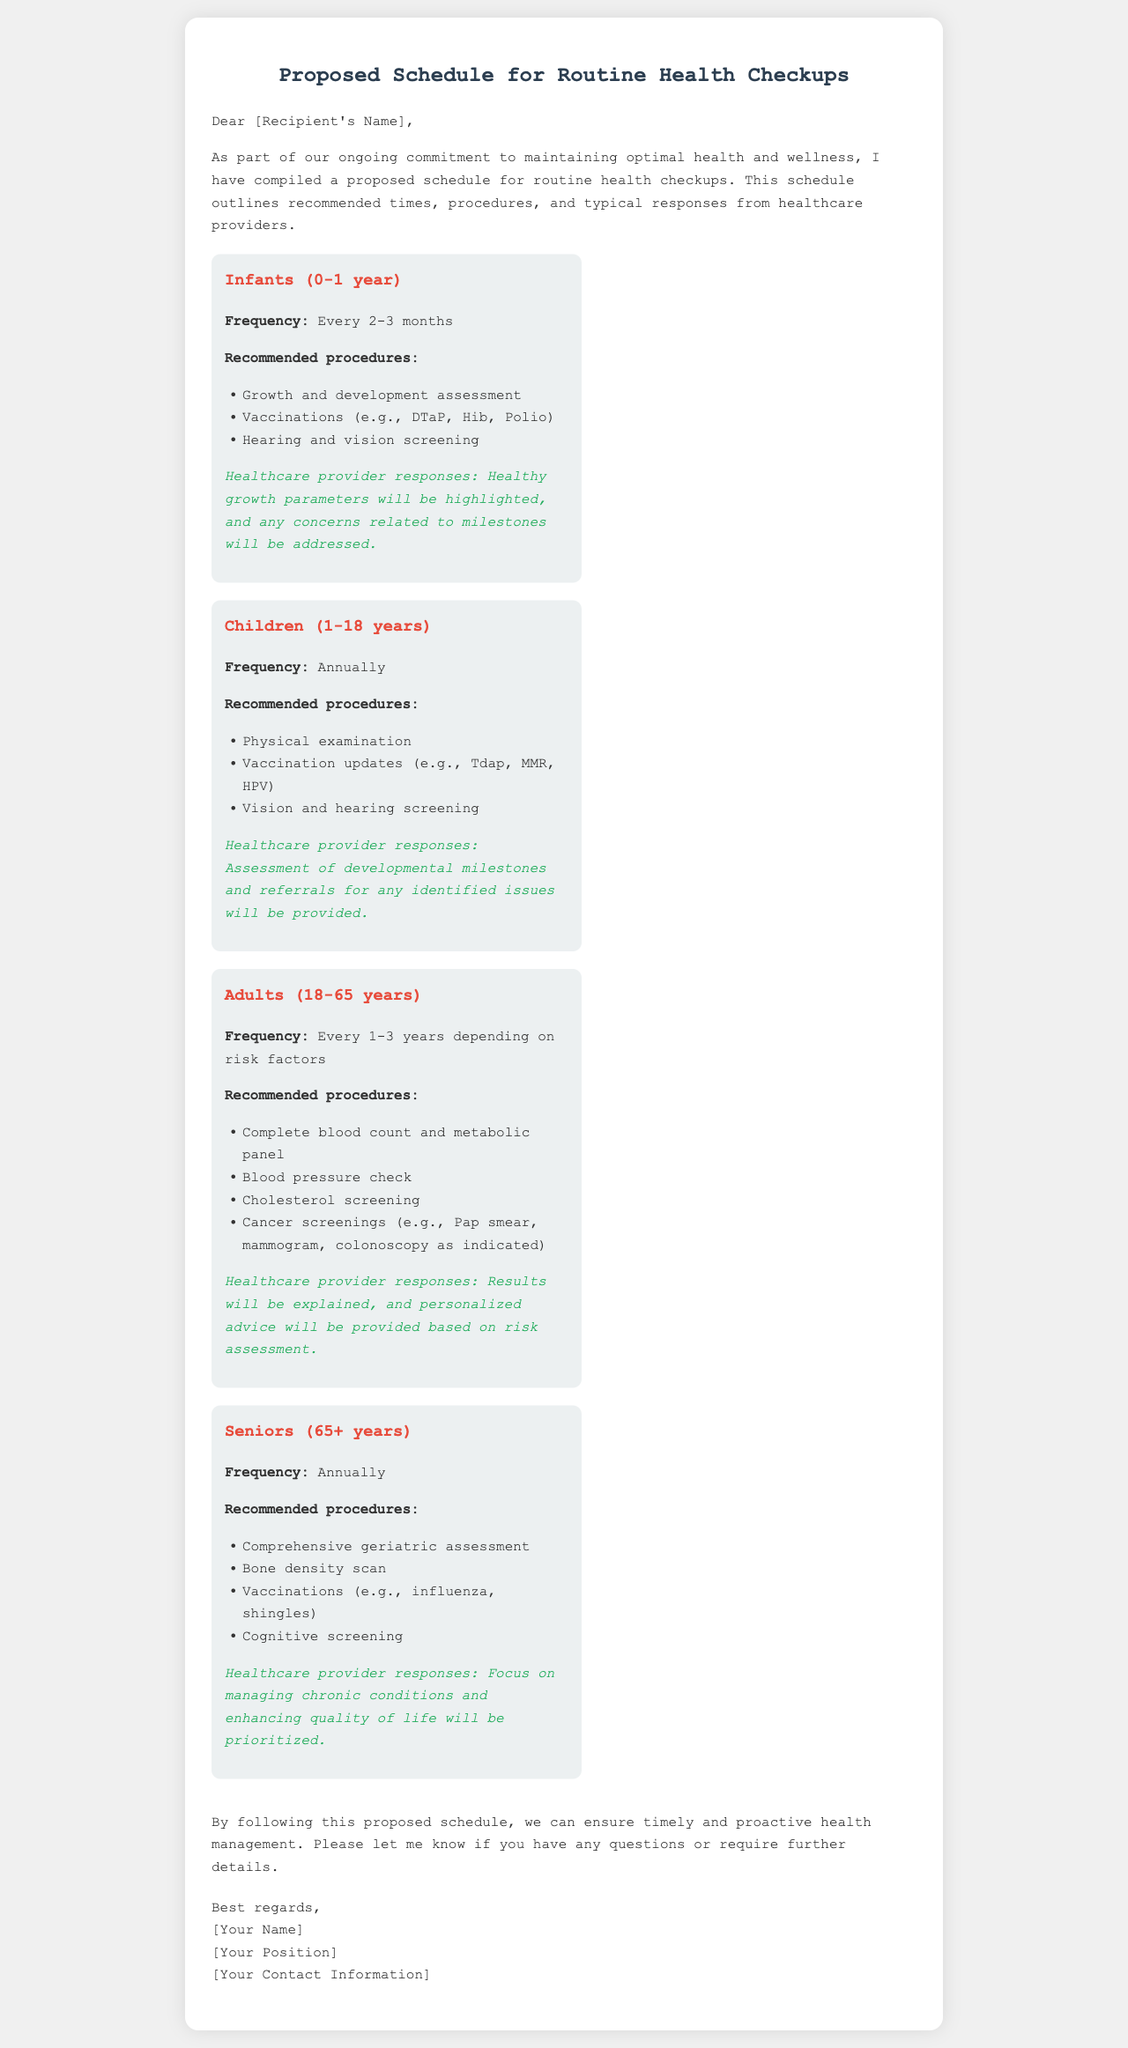What is the frequency for infants' health checkups? The frequency for infants' health checkups is specified in the document as every 2-3 months.
Answer: Every 2-3 months What procedures are recommended for adults? The procedures recommended for adults include several health assessments detailed in the document, such as blood tests and screenings.
Answer: Complete blood count and metabolic panel, Blood pressure check, Cholesterol screening, Cancer screenings How often should seniors have checkups? The document states the frequency for seniors' health checkups, which is important for their health management.
Answer: Annually What is the age range for children in the health checkup schedule? The age range for children is clearly defined in the document as 1-18 years.
Answer: 1-18 years What is a key focus for care during senior checkups? The document highlights the focus areas during senior checkups, which provides insight into their healthcare needs.
Answer: Managing chronic conditions and enhancing quality of life What typical response is expected from healthcare providers for infants? The expected response from healthcare providers regarding infants is mentioned in the document, outlining their feedback.
Answer: Healthy growth parameters will be highlighted What is the title of the document? The title summarizes the subject of the email, giving an overview of the content.
Answer: Proposed Schedule for Routine Health Checkups What section provides the conclusion of the email? The conclusion section of the email reinforces the purpose and encourages further communication.
Answer: Conclusion What should recipients do if they have questions about the schedule? The document informs recipients about the next steps if they require additional information or clarifications.
Answer: Let me know if you have any questions 